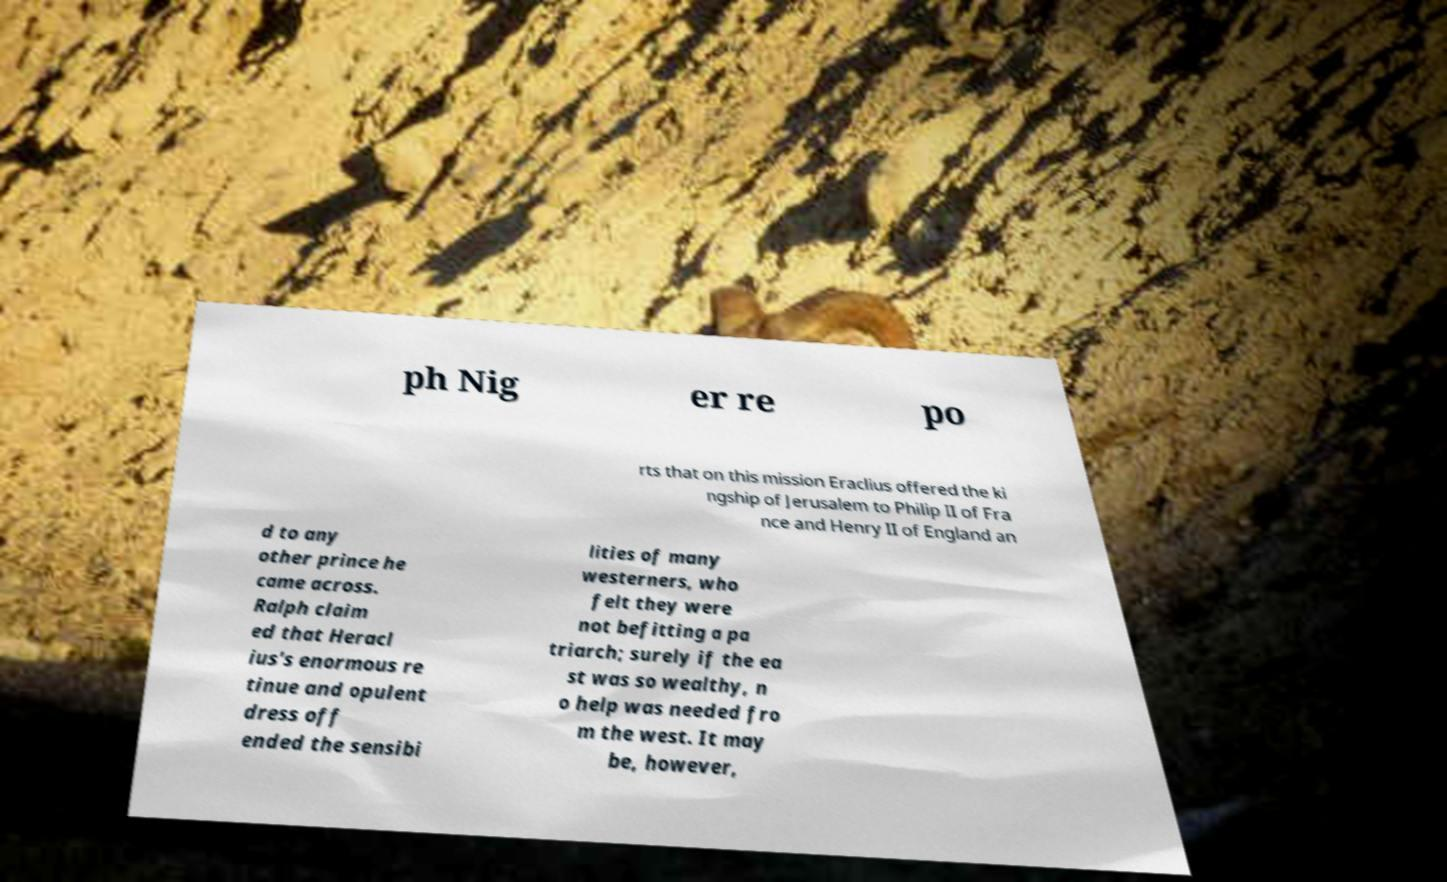What messages or text are displayed in this image? I need them in a readable, typed format. ph Nig er re po rts that on this mission Eraclius offered the ki ngship of Jerusalem to Philip II of Fra nce and Henry II of England an d to any other prince he came across. Ralph claim ed that Heracl ius's enormous re tinue and opulent dress off ended the sensibi lities of many westerners, who felt they were not befitting a pa triarch; surely if the ea st was so wealthy, n o help was needed fro m the west. It may be, however, 